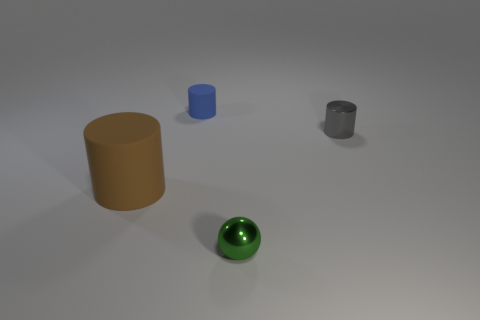Is the size of the metallic object to the right of the green shiny thing the same as the big brown thing?
Provide a short and direct response. No. Is the small cylinder in front of the small blue matte cylinder made of the same material as the object in front of the large brown object?
Make the answer very short. Yes. Are there any purple spheres of the same size as the gray cylinder?
Ensure brevity in your answer.  No. There is a tiny metal object that is in front of the matte object to the left of the rubber cylinder right of the large rubber thing; what is its shape?
Offer a terse response. Sphere. Is the number of small gray cylinders left of the brown cylinder greater than the number of big green metallic cylinders?
Provide a short and direct response. No. Are there any cyan metal objects that have the same shape as the large brown rubber thing?
Keep it short and to the point. No. Are the small green thing and the cylinder left of the tiny matte cylinder made of the same material?
Provide a short and direct response. No. The large thing is what color?
Make the answer very short. Brown. What number of rubber objects are right of the matte cylinder in front of the small thing behind the gray shiny object?
Your answer should be very brief. 1. Are there any blue rubber cylinders in front of the small blue matte cylinder?
Your response must be concise. No. 